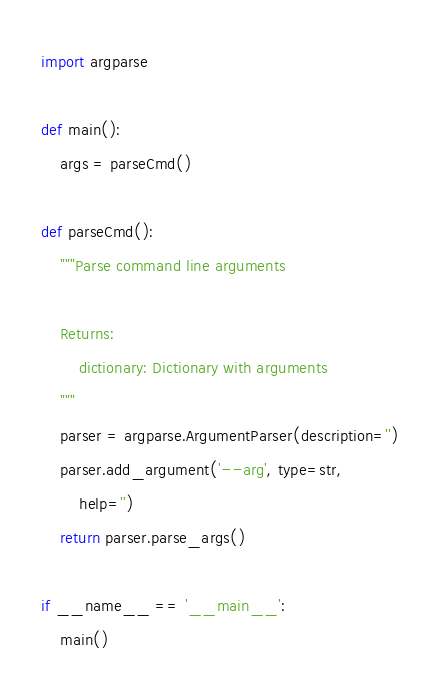Convert code to text. <code><loc_0><loc_0><loc_500><loc_500><_Python_>import argparse

def main():
    args = parseCmd()

def parseCmd():
    """Parse command line arguments

    Returns:
        dictionary: Dictionary with arguments
    """
    parser = argparse.ArgumentParser(description='')
    parser.add_argument('--arg', type=str,
        help='')
    return parser.parse_args()

if __name__ == '__main__':
    main()
</code> 